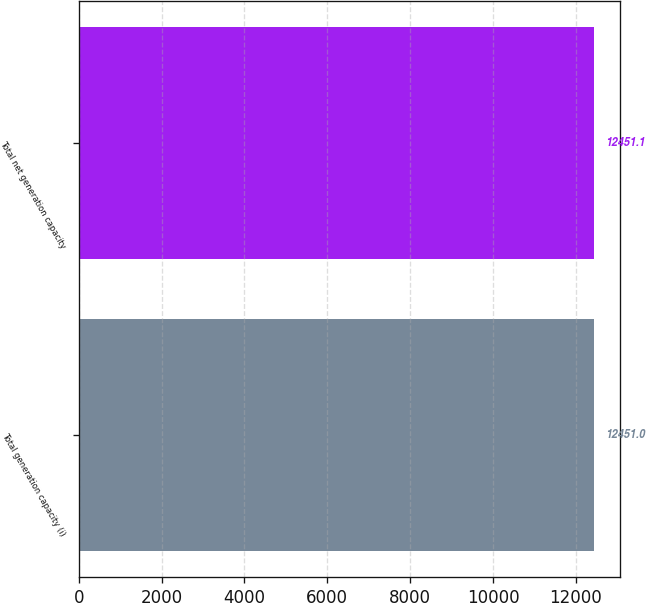<chart> <loc_0><loc_0><loc_500><loc_500><bar_chart><fcel>Total generation capacity (i)<fcel>Total net generation capacity<nl><fcel>12451<fcel>12451.1<nl></chart> 